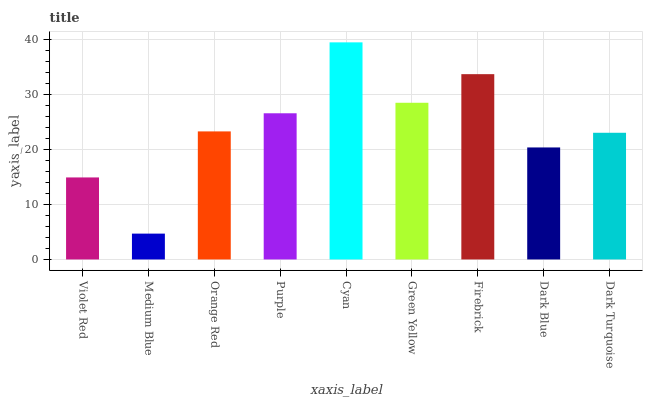Is Medium Blue the minimum?
Answer yes or no. Yes. Is Cyan the maximum?
Answer yes or no. Yes. Is Orange Red the minimum?
Answer yes or no. No. Is Orange Red the maximum?
Answer yes or no. No. Is Orange Red greater than Medium Blue?
Answer yes or no. Yes. Is Medium Blue less than Orange Red?
Answer yes or no. Yes. Is Medium Blue greater than Orange Red?
Answer yes or no. No. Is Orange Red less than Medium Blue?
Answer yes or no. No. Is Orange Red the high median?
Answer yes or no. Yes. Is Orange Red the low median?
Answer yes or no. Yes. Is Firebrick the high median?
Answer yes or no. No. Is Firebrick the low median?
Answer yes or no. No. 